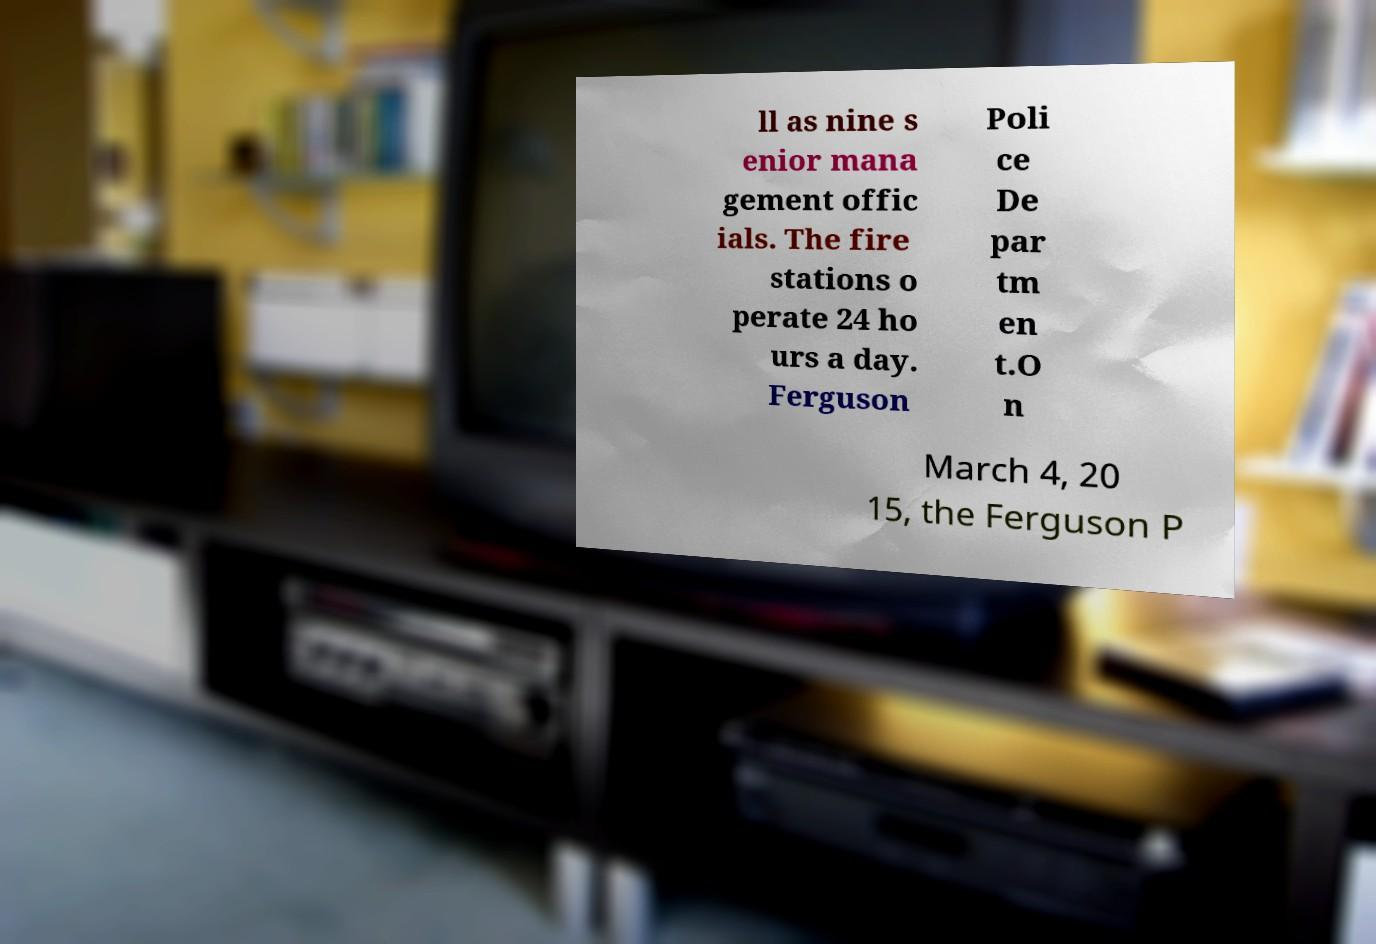For documentation purposes, I need the text within this image transcribed. Could you provide that? ll as nine s enior mana gement offic ials. The fire stations o perate 24 ho urs a day. Ferguson Poli ce De par tm en t.O n March 4, 20 15, the Ferguson P 